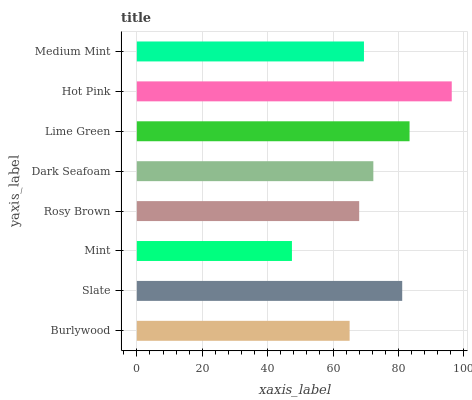Is Mint the minimum?
Answer yes or no. Yes. Is Hot Pink the maximum?
Answer yes or no. Yes. Is Slate the minimum?
Answer yes or no. No. Is Slate the maximum?
Answer yes or no. No. Is Slate greater than Burlywood?
Answer yes or no. Yes. Is Burlywood less than Slate?
Answer yes or no. Yes. Is Burlywood greater than Slate?
Answer yes or no. No. Is Slate less than Burlywood?
Answer yes or no. No. Is Dark Seafoam the high median?
Answer yes or no. Yes. Is Medium Mint the low median?
Answer yes or no. Yes. Is Lime Green the high median?
Answer yes or no. No. Is Slate the low median?
Answer yes or no. No. 